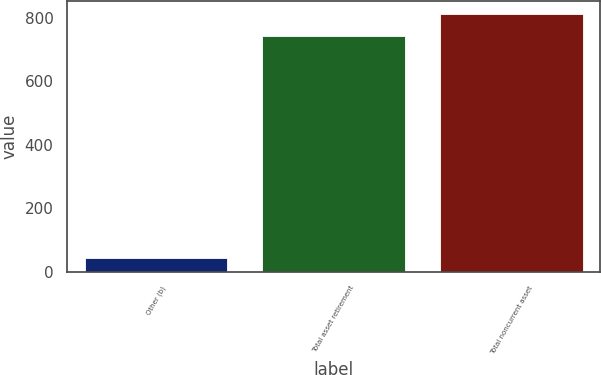Convert chart to OTSL. <chart><loc_0><loc_0><loc_500><loc_500><bar_chart><fcel>Other (b)<fcel>Total asset retirement<fcel>Total noncurrent asset<nl><fcel>42<fcel>742<fcel>812<nl></chart> 